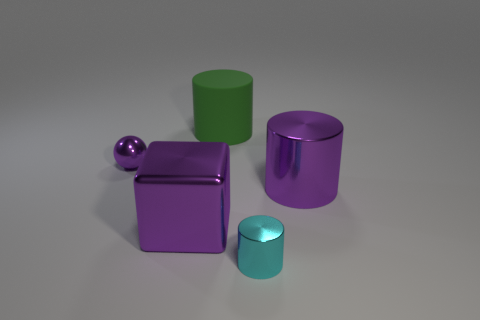What number of shiny cylinders are there?
Your answer should be very brief. 2. The tiny thing to the right of the small metal thing that is to the left of the big green matte cylinder that is behind the cyan shiny thing is what color?
Keep it short and to the point. Cyan. Does the big matte cylinder have the same color as the small cylinder?
Offer a terse response. No. What number of things are behind the tiny sphere and right of the tiny cyan metal cylinder?
Make the answer very short. 0. What number of rubber objects are large cylinders or purple objects?
Your response must be concise. 1. The tiny thing in front of the large shiny thing to the right of the big metal block is made of what material?
Provide a succinct answer. Metal. There is a tiny thing that is the same color as the large metal cube; what is its shape?
Offer a very short reply. Sphere. There is a purple thing that is the same size as the cyan metal thing; what shape is it?
Provide a short and direct response. Sphere. Are there fewer purple cylinders than big blue objects?
Offer a terse response. No. There is a metallic cylinder that is right of the cyan cylinder; are there any green matte cylinders that are on the right side of it?
Provide a short and direct response. No. 